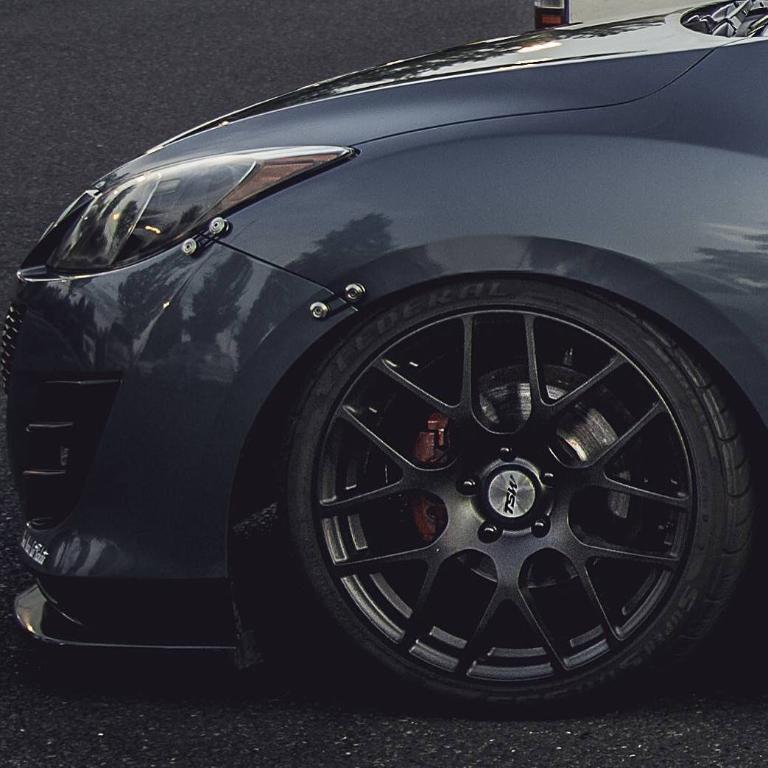Describe this image in one or two sentences. This is a picture of the front part of the black color car which is on the road. 